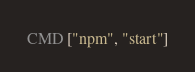Convert code to text. <code><loc_0><loc_0><loc_500><loc_500><_Dockerfile_>CMD ["npm", "start"]
</code> 